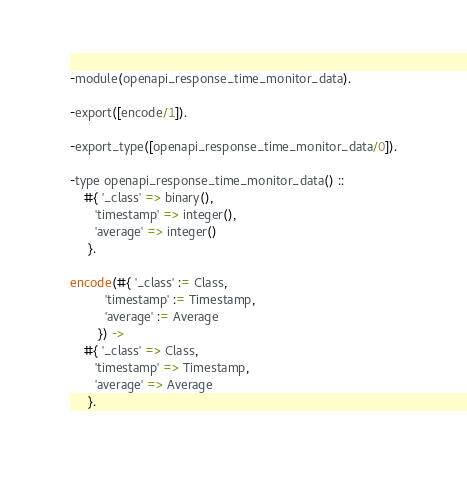<code> <loc_0><loc_0><loc_500><loc_500><_Erlang_>-module(openapi_response_time_monitor_data).

-export([encode/1]).

-export_type([openapi_response_time_monitor_data/0]).

-type openapi_response_time_monitor_data() ::
    #{ '_class' => binary(),
       'timestamp' => integer(),
       'average' => integer()
     }.

encode(#{ '_class' := Class,
          'timestamp' := Timestamp,
          'average' := Average
        }) ->
    #{ '_class' => Class,
       'timestamp' => Timestamp,
       'average' => Average
     }.
</code> 